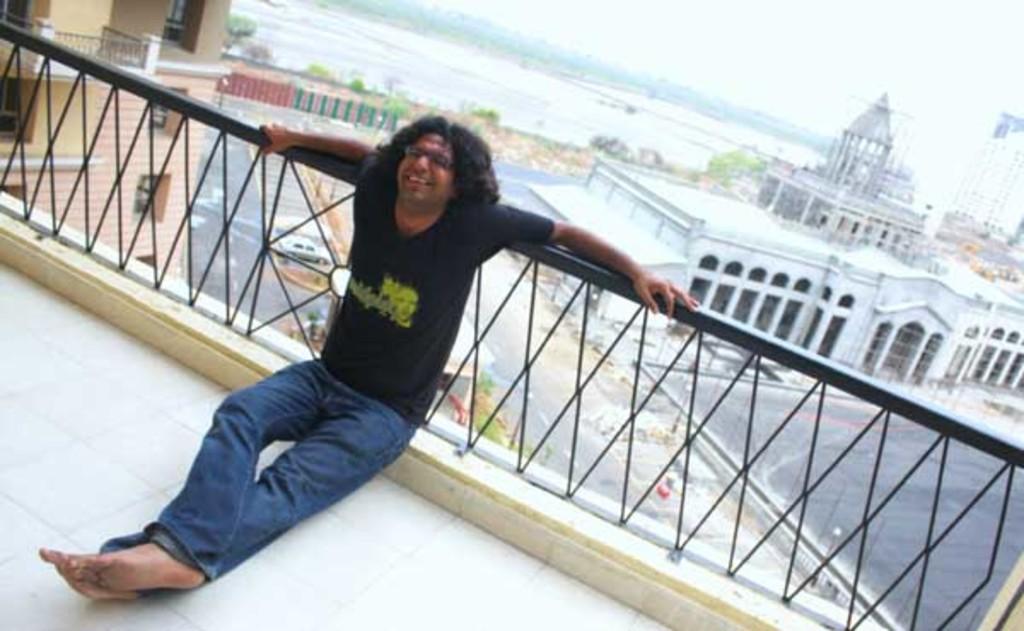In one or two sentences, can you explain what this image depicts? In this image I can see a man in the front and I can see he is wearing blue colour jeans, black colour t shirt and a specs. Behind him I can see railing, few buildings, few trees and a car. 